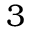<formula> <loc_0><loc_0><loc_500><loc_500>3</formula> 